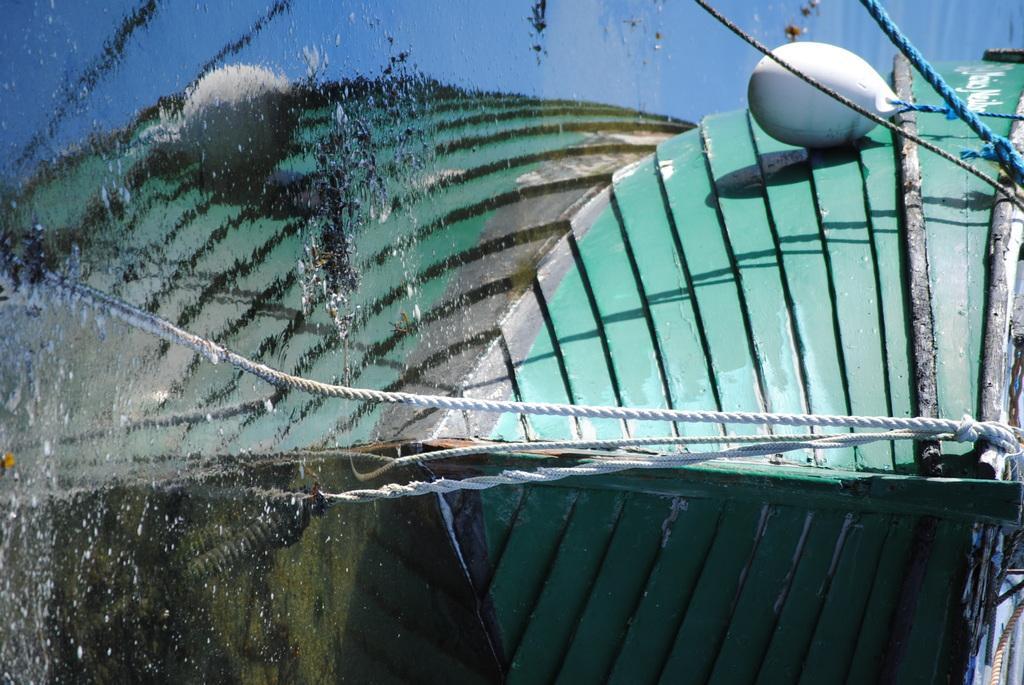Could you give a brief overview of what you see in this image? In this image there is a boat, on the water and there are tapes. 